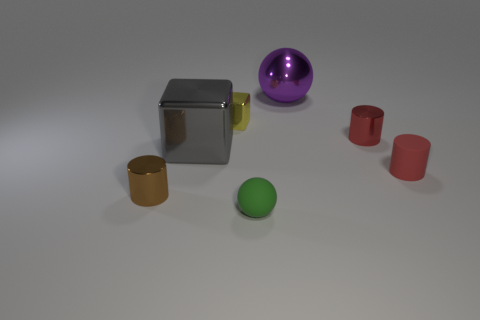Is the purple object the same shape as the small green rubber thing? The purple object appears to be spherical, much like the small green item, which also exhibits a spherical shape. Despite variations in scale and material, they share the same geometric form. 